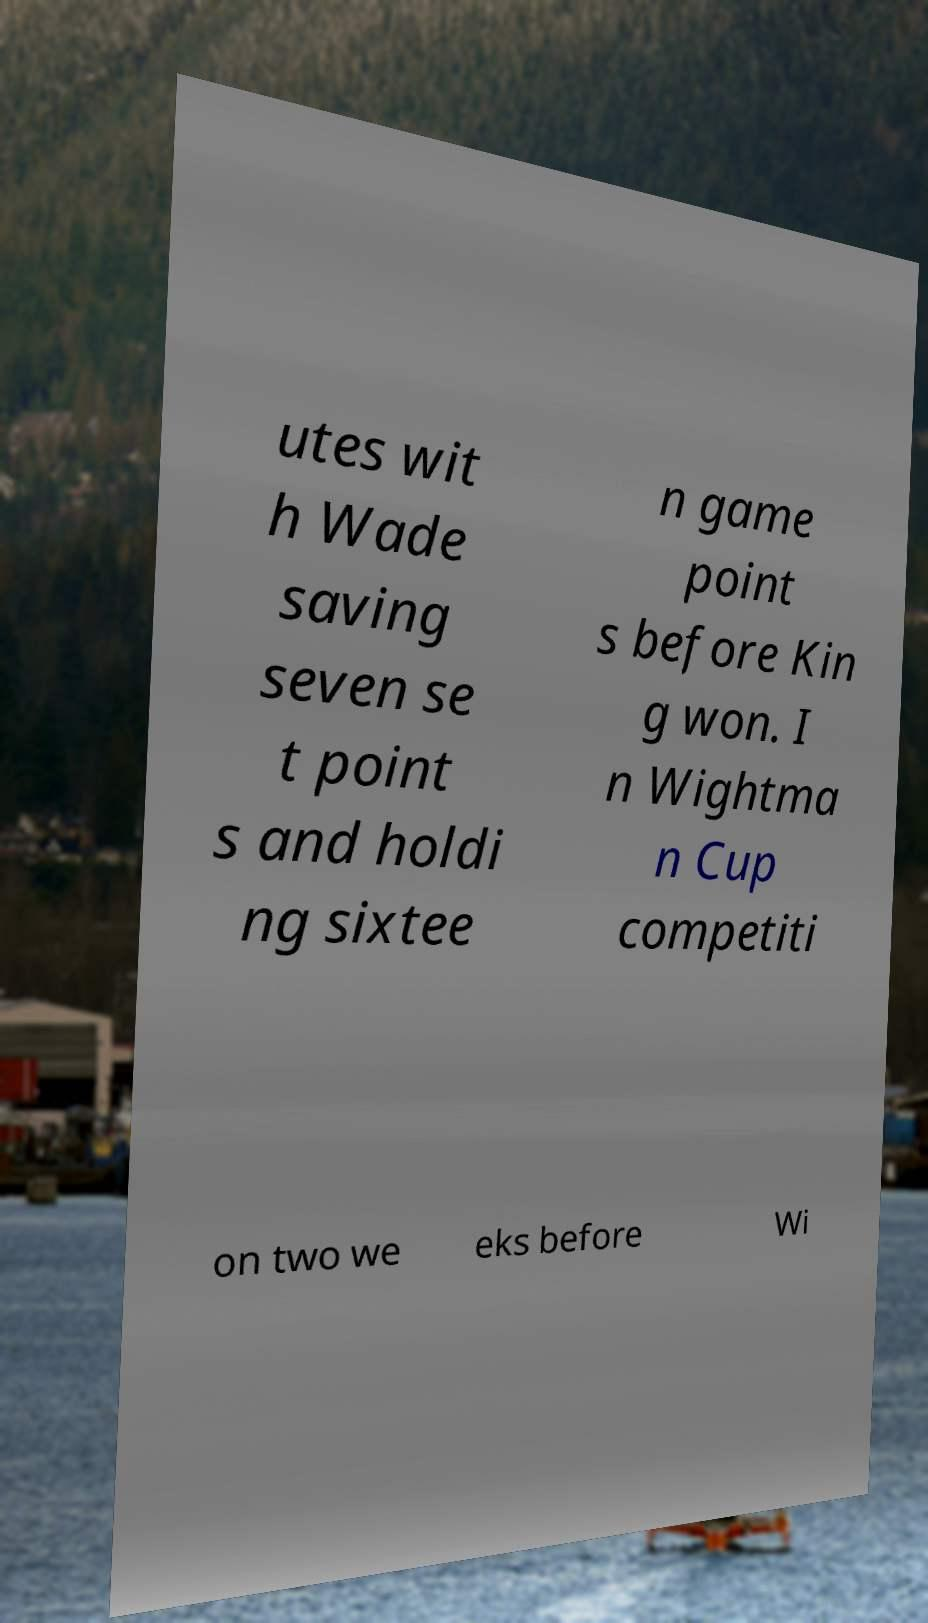I need the written content from this picture converted into text. Can you do that? utes wit h Wade saving seven se t point s and holdi ng sixtee n game point s before Kin g won. I n Wightma n Cup competiti on two we eks before Wi 